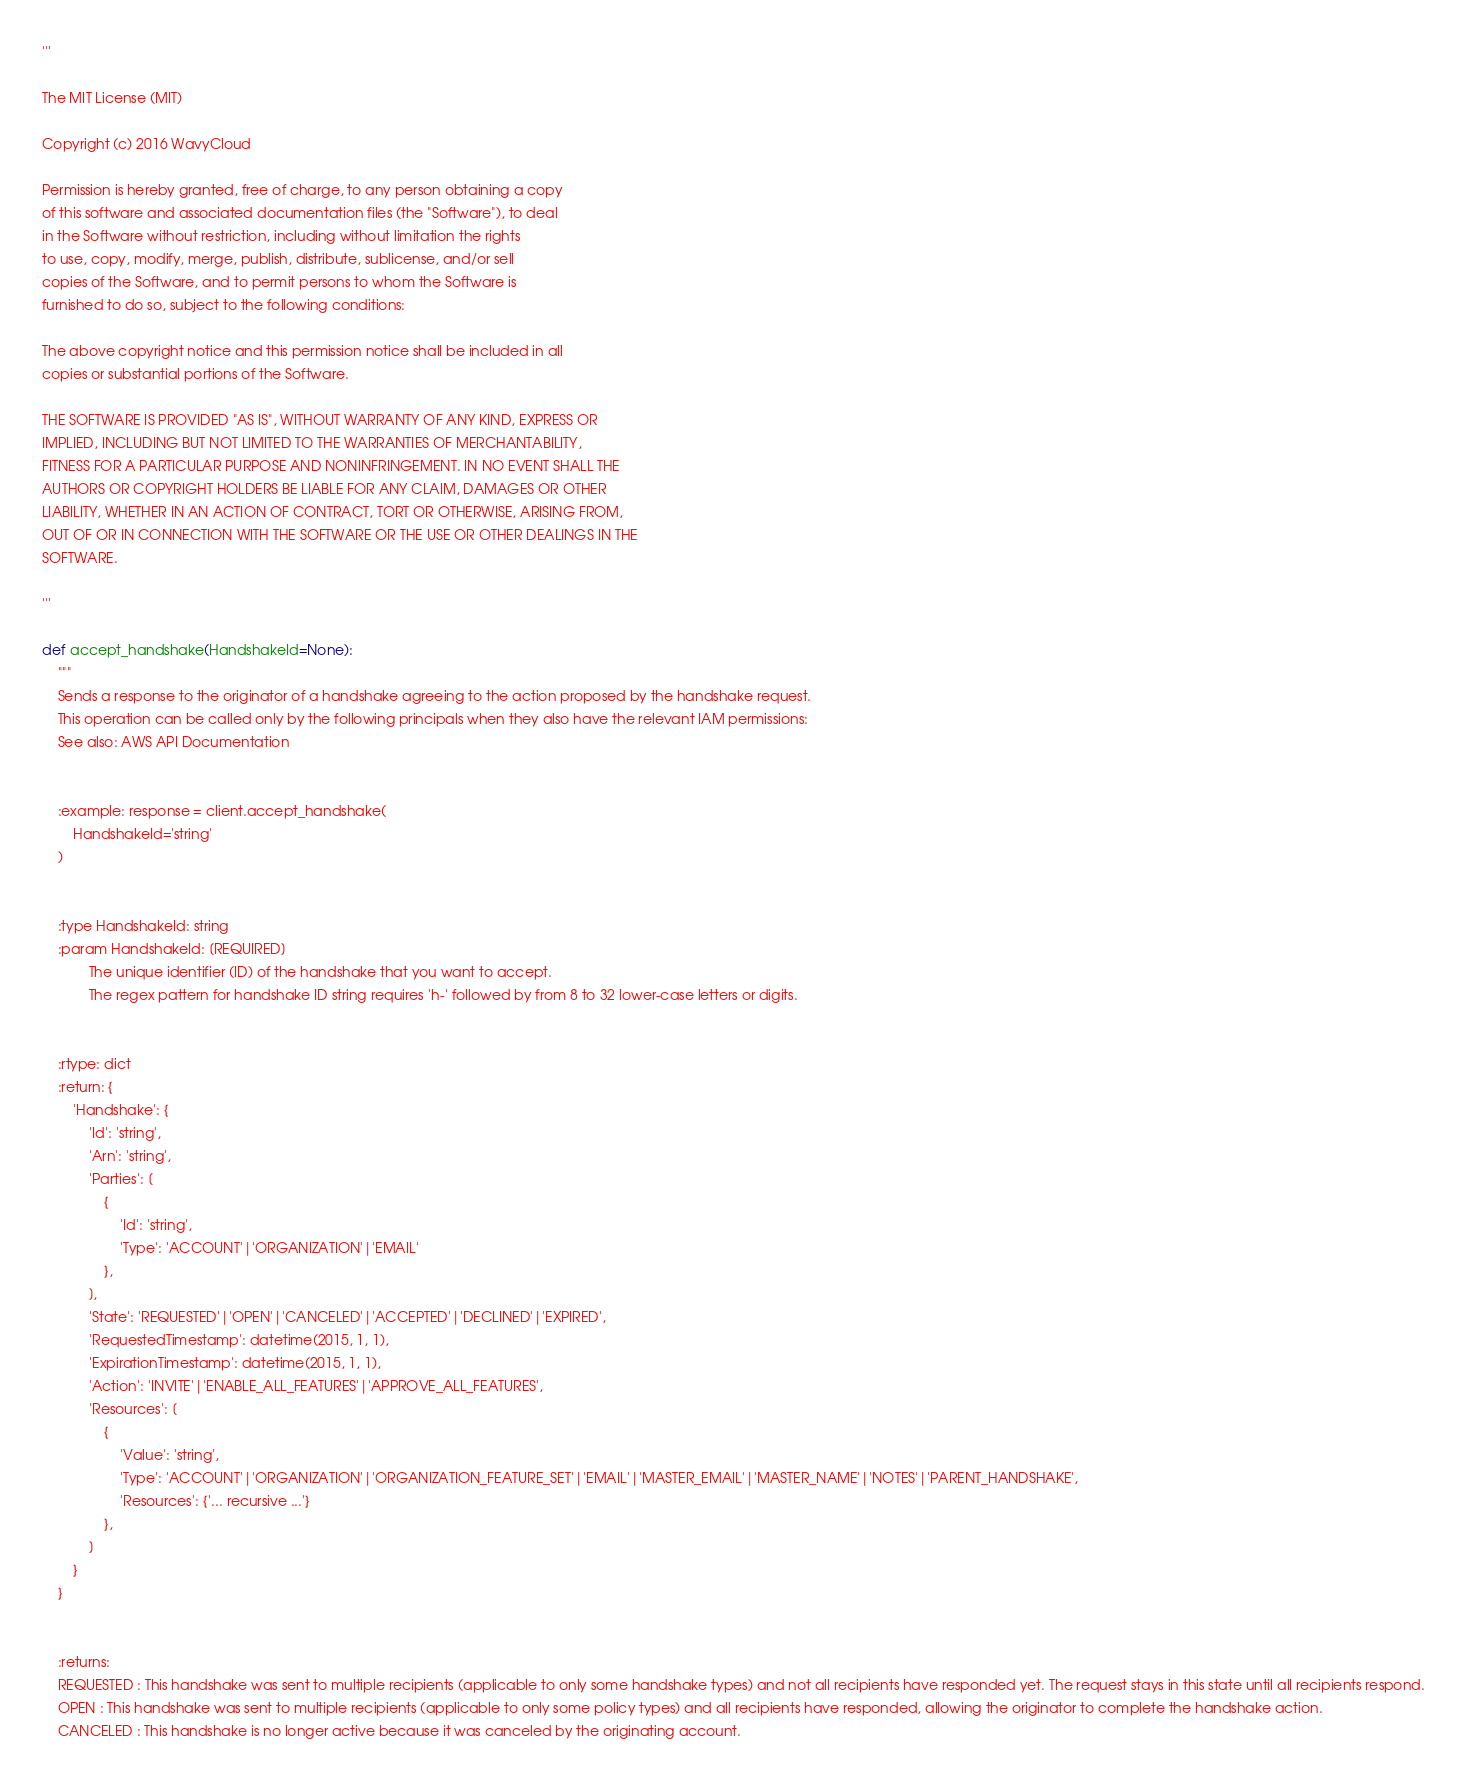<code> <loc_0><loc_0><loc_500><loc_500><_Python_>'''

The MIT License (MIT)

Copyright (c) 2016 WavyCloud

Permission is hereby granted, free of charge, to any person obtaining a copy
of this software and associated documentation files (the "Software"), to deal
in the Software without restriction, including without limitation the rights
to use, copy, modify, merge, publish, distribute, sublicense, and/or sell
copies of the Software, and to permit persons to whom the Software is
furnished to do so, subject to the following conditions:

The above copyright notice and this permission notice shall be included in all
copies or substantial portions of the Software.

THE SOFTWARE IS PROVIDED "AS IS", WITHOUT WARRANTY OF ANY KIND, EXPRESS OR
IMPLIED, INCLUDING BUT NOT LIMITED TO THE WARRANTIES OF MERCHANTABILITY,
FITNESS FOR A PARTICULAR PURPOSE AND NONINFRINGEMENT. IN NO EVENT SHALL THE
AUTHORS OR COPYRIGHT HOLDERS BE LIABLE FOR ANY CLAIM, DAMAGES OR OTHER
LIABILITY, WHETHER IN AN ACTION OF CONTRACT, TORT OR OTHERWISE, ARISING FROM,
OUT OF OR IN CONNECTION WITH THE SOFTWARE OR THE USE OR OTHER DEALINGS IN THE
SOFTWARE.

'''

def accept_handshake(HandshakeId=None):
    """
    Sends a response to the originator of a handshake agreeing to the action proposed by the handshake request.
    This operation can be called only by the following principals when they also have the relevant IAM permissions:
    See also: AWS API Documentation
    
    
    :example: response = client.accept_handshake(
        HandshakeId='string'
    )
    
    
    :type HandshakeId: string
    :param HandshakeId: [REQUIRED]
            The unique identifier (ID) of the handshake that you want to accept.
            The regex pattern for handshake ID string requires 'h-' followed by from 8 to 32 lower-case letters or digits.
            

    :rtype: dict
    :return: {
        'Handshake': {
            'Id': 'string',
            'Arn': 'string',
            'Parties': [
                {
                    'Id': 'string',
                    'Type': 'ACCOUNT'|'ORGANIZATION'|'EMAIL'
                },
            ],
            'State': 'REQUESTED'|'OPEN'|'CANCELED'|'ACCEPTED'|'DECLINED'|'EXPIRED',
            'RequestedTimestamp': datetime(2015, 1, 1),
            'ExpirationTimestamp': datetime(2015, 1, 1),
            'Action': 'INVITE'|'ENABLE_ALL_FEATURES'|'APPROVE_ALL_FEATURES',
            'Resources': [
                {
                    'Value': 'string',
                    'Type': 'ACCOUNT'|'ORGANIZATION'|'ORGANIZATION_FEATURE_SET'|'EMAIL'|'MASTER_EMAIL'|'MASTER_NAME'|'NOTES'|'PARENT_HANDSHAKE',
                    'Resources': {'... recursive ...'}
                },
            ]
        }
    }
    
    
    :returns: 
    REQUESTED : This handshake was sent to multiple recipients (applicable to only some handshake types) and not all recipients have responded yet. The request stays in this state until all recipients respond.
    OPEN : This handshake was sent to multiple recipients (applicable to only some policy types) and all recipients have responded, allowing the originator to complete the handshake action.
    CANCELED : This handshake is no longer active because it was canceled by the originating account.</code> 